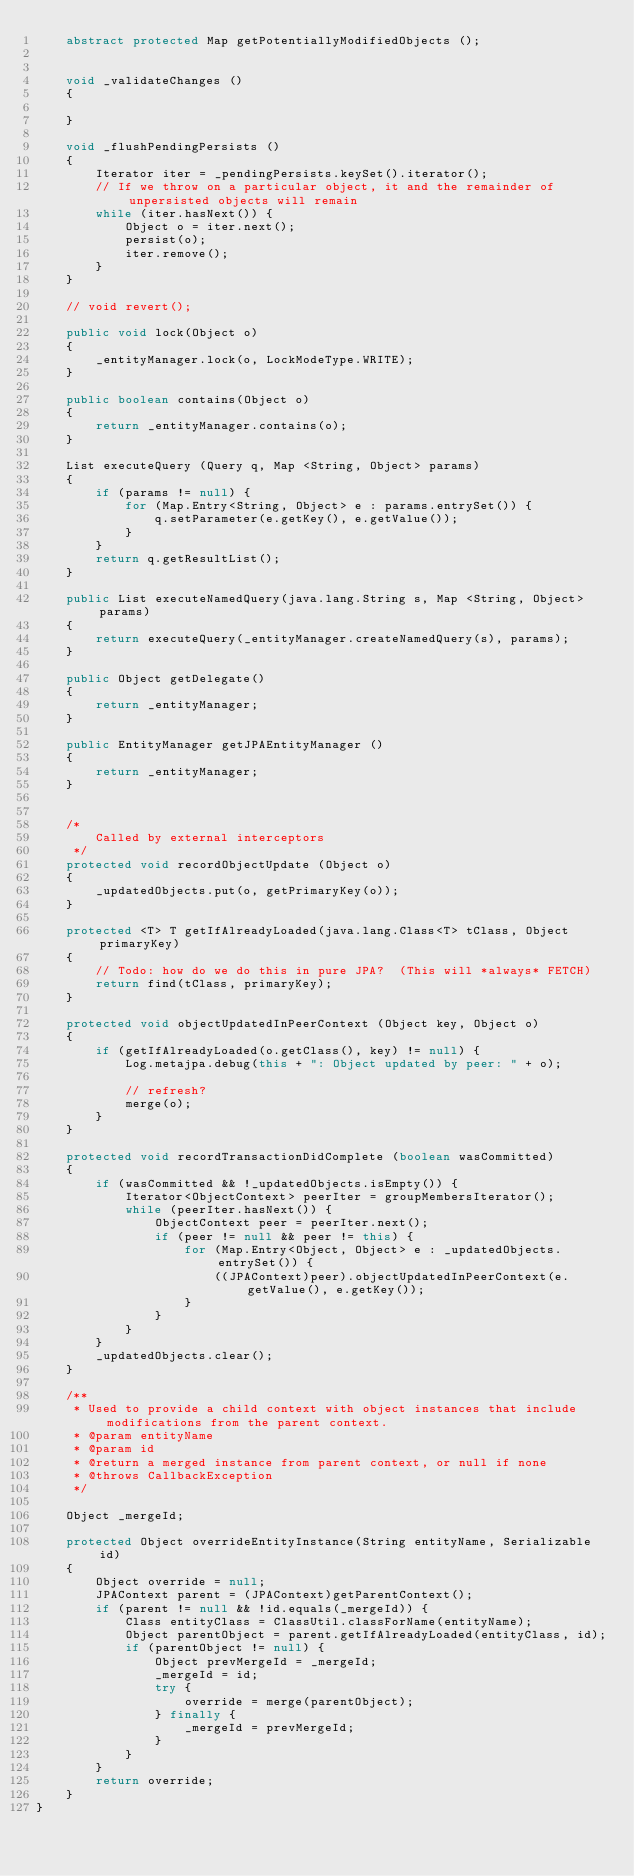<code> <loc_0><loc_0><loc_500><loc_500><_Java_>    abstract protected Map getPotentiallyModifiedObjects ();


    void _validateChanges ()
    {

    }

    void _flushPendingPersists ()
    {
        Iterator iter = _pendingPersists.keySet().iterator();
        // If we throw on a particular object, it and the remainder of unpersisted objects will remain
        while (iter.hasNext()) {
            Object o = iter.next();
            persist(o);
            iter.remove();
        }
    }

    // void revert();

    public void lock(Object o)
    {
        _entityManager.lock(o, LockModeType.WRITE);
    }

    public boolean contains(Object o)
    {
        return _entityManager.contains(o);
    }

    List executeQuery (Query q, Map <String, Object> params)
    {
        if (params != null) {
            for (Map.Entry<String, Object> e : params.entrySet()) {
                q.setParameter(e.getKey(), e.getValue());
            }
        }
        return q.getResultList();
    }

    public List executeNamedQuery(java.lang.String s, Map <String, Object> params)
    {
        return executeQuery(_entityManager.createNamedQuery(s), params);
    }

    public Object getDelegate()
    {
        return _entityManager;
    }

    public EntityManager getJPAEntityManager ()
    {
        return _entityManager;
    }


    /*
        Called by external interceptors
     */
    protected void recordObjectUpdate (Object o)
    {
        _updatedObjects.put(o, getPrimaryKey(o));
    }

    protected <T> T getIfAlreadyLoaded(java.lang.Class<T> tClass, Object primaryKey)
    {
        // Todo: how do we do this in pure JPA?  (This will *always* FETCH)
        return find(tClass, primaryKey);
    }

    protected void objectUpdatedInPeerContext (Object key, Object o)
    {
        if (getIfAlreadyLoaded(o.getClass(), key) != null) {
            Log.metajpa.debug(this + ": Object updated by peer: " + o);

            // refresh?
            merge(o);
        }
    }

    protected void recordTransactionDidComplete (boolean wasCommitted)
    {
        if (wasCommitted && !_updatedObjects.isEmpty()) {
            Iterator<ObjectContext> peerIter = groupMembersIterator();
            while (peerIter.hasNext()) {
                ObjectContext peer = peerIter.next();
                if (peer != null && peer != this) {
                    for (Map.Entry<Object, Object> e : _updatedObjects.entrySet()) {
                        ((JPAContext)peer).objectUpdatedInPeerContext(e.getValue(), e.getKey());
                    }
                }
            }
        }
        _updatedObjects.clear();
    }

    /**
     * Used to provide a child context with object instances that include modifications from the parent context.
     * @param entityName
     * @param id
     * @return a merged instance from parent context, or null if none
     * @throws CallbackException
     */

    Object _mergeId;

    protected Object overrideEntityInstance(String entityName, Serializable id)
    {
        Object override = null;
        JPAContext parent = (JPAContext)getParentContext();
        if (parent != null && !id.equals(_mergeId)) {
            Class entityClass = ClassUtil.classForName(entityName);
            Object parentObject = parent.getIfAlreadyLoaded(entityClass, id);
            if (parentObject != null) {
                Object prevMergeId = _mergeId;
                _mergeId = id;
                try {
                    override = merge(parentObject);
                } finally {
                    _mergeId = prevMergeId;
                }
            }
        }
        return override;
    }
}
</code> 